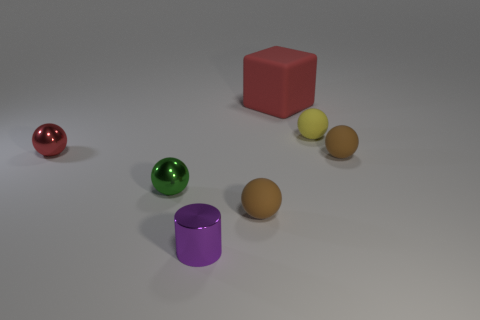What can you say about the overall setup or arrangement of the objects? The objects are placed in a way that appears deliberate, possibly to create a simple visual composition with an emphasis on the shapes and colors rather than any real-world context. The spherical items along with the cube and cylinder allow for an exploration of the way light interacts with different geometric forms. 